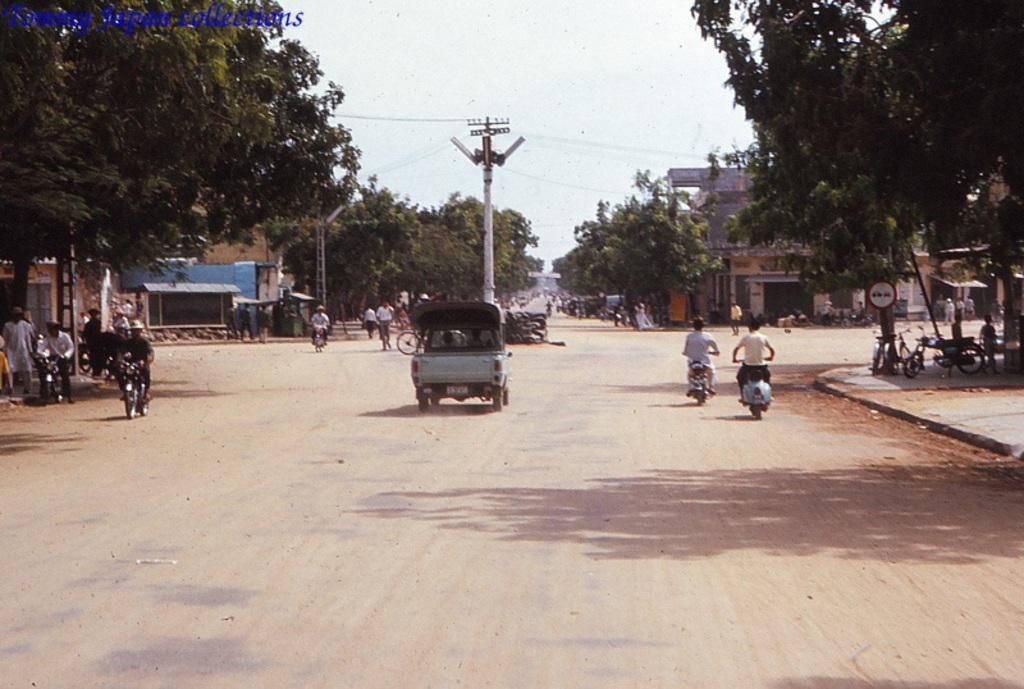Please provide a concise description of this image. In this image on the road many vehicles are moving. Few persons are riding bikes. On the both sides of the image there are trees. In the background there are buildings,trees. Here there is an electric pole. The sky is clear. 